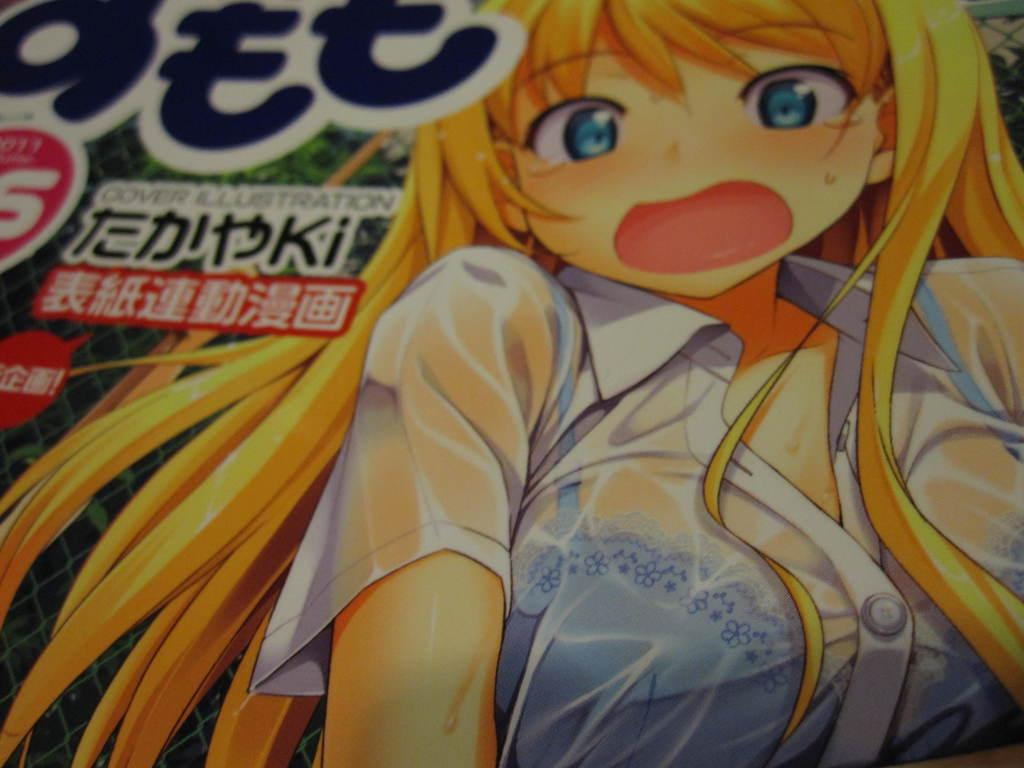What is depicted on the board in the image? There is a cartoon on the board in the image. What type of house is shown in the cartoon on the board? There is no house depicted in the cartoon on the board; it only features a cartoon. What color is the shirt worn by the cartoon character in the image? There is no shirt worn by a cartoon character in the image, as the cartoon does not depict a character with clothing. 